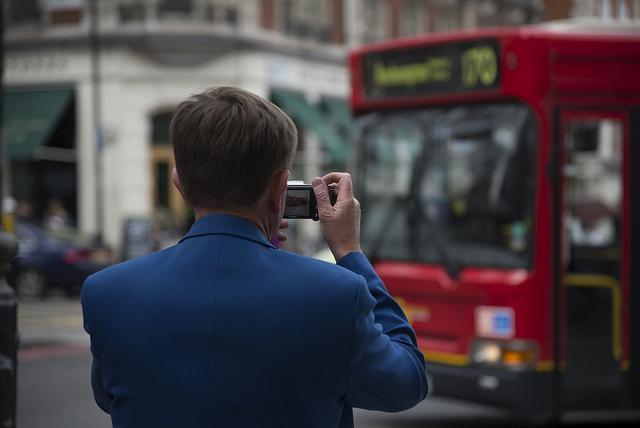Does the description: "The bus is in front of the person." accurately reflect the image?
Answer yes or no. Yes. Is the caption "The bus is ahead of the person." a true representation of the image?
Answer yes or no. Yes. Is this affirmation: "The bus contains the person." correct?
Answer yes or no. No. 